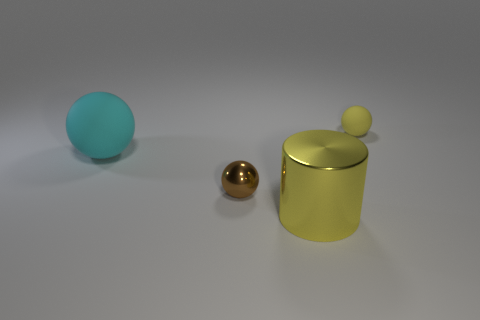How many objects are either rubber objects on the left side of the brown metallic thing or tiny yellow metallic balls? In the image, there appears to be just one rubber object on the left side of the brown metallic item, which is a large blue ball. There are no tiny yellow metallic balls present. Therefore, the total count of objects meeting the criteria is one. 